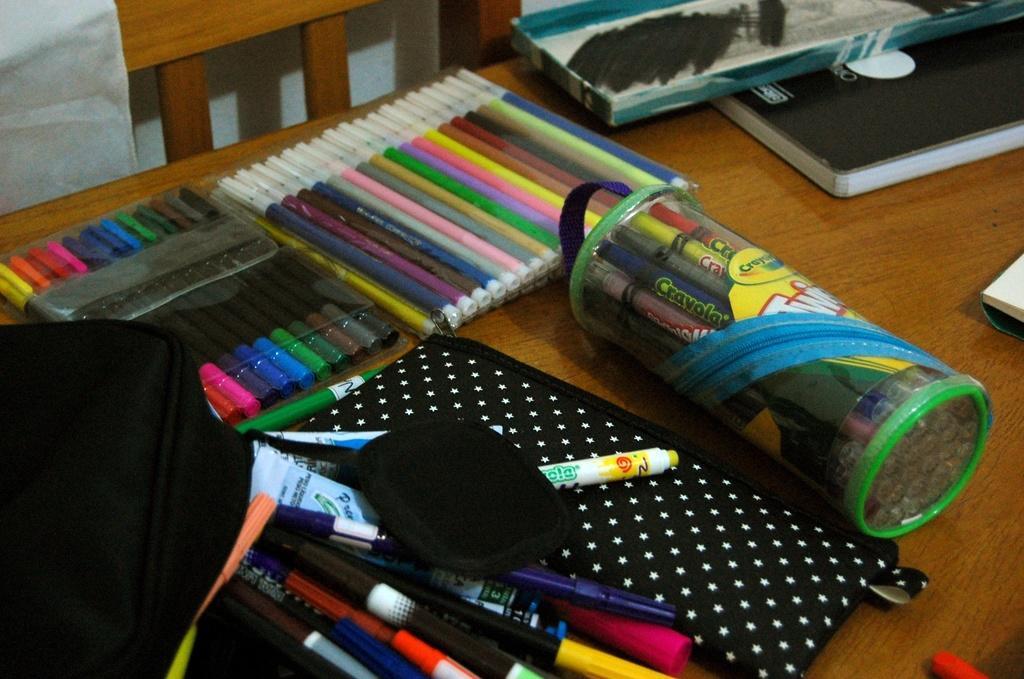Please provide a concise description of this image. In this image we can see sketch pens, pens, pouches and other objects. In the background of the image there is a wooden chair, table and other objects. 